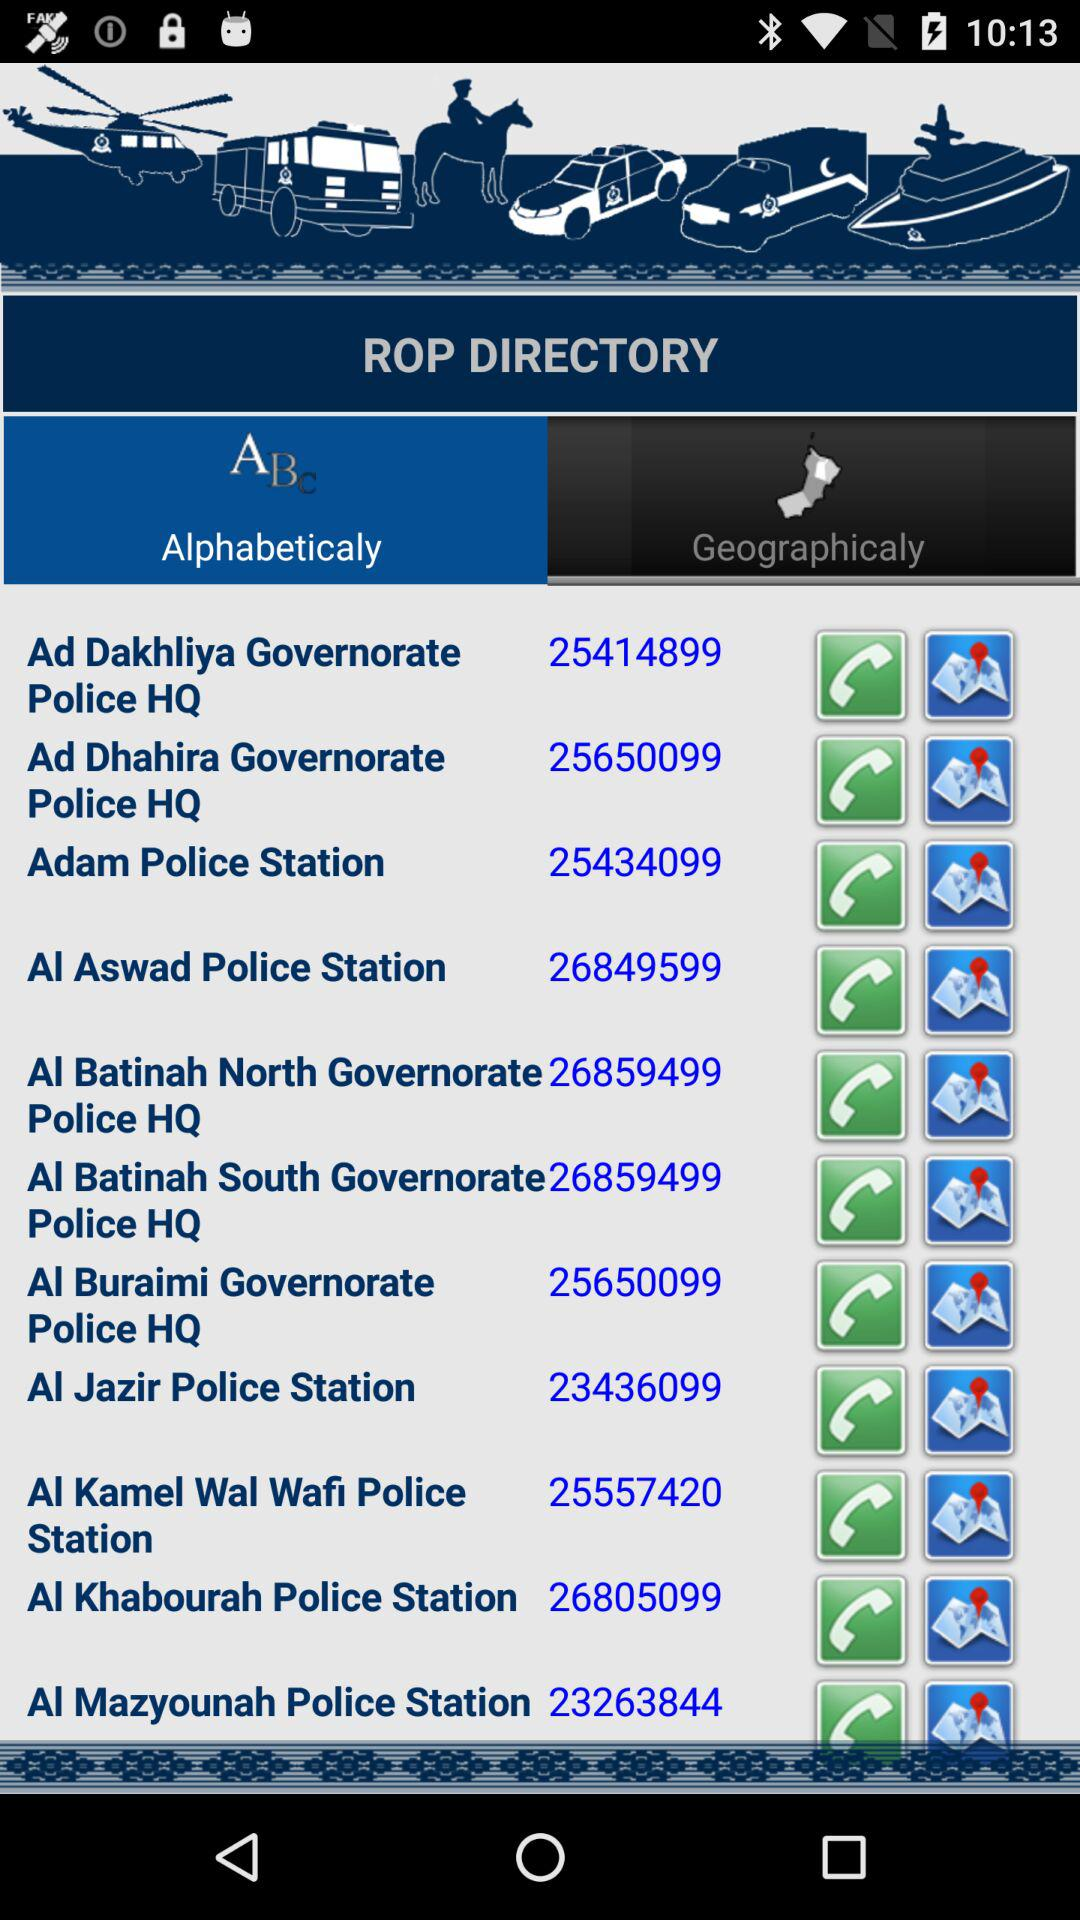What's the number for "Ad Dakhliya Governorate Police HQ"? The number is 25414899. 